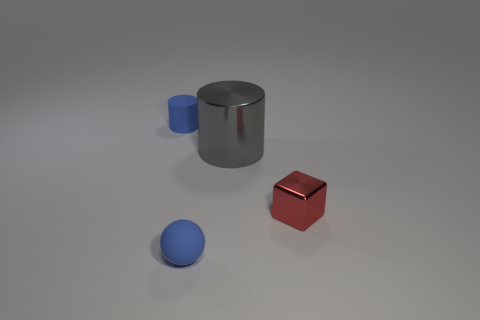Do the rubber cylinder and the matte thing in front of the shiny cylinder have the same color?
Make the answer very short. Yes. Is the number of small blue spheres right of the sphere the same as the number of big things that are in front of the small red block?
Provide a short and direct response. Yes. What number of other objects are there of the same size as the matte ball?
Make the answer very short. 2. The metallic cylinder is what size?
Your answer should be very brief. Large. Are the tiny cube and the blue object that is behind the small matte sphere made of the same material?
Your answer should be compact. No. Is there another big gray shiny thing that has the same shape as the big metallic thing?
Your answer should be very brief. No. What material is the cube that is the same size as the blue cylinder?
Offer a terse response. Metal. There is a rubber object that is in front of the tiny shiny thing; what size is it?
Your response must be concise. Small. Is the size of the blue thing that is behind the large gray shiny thing the same as the blue matte thing that is in front of the gray metallic thing?
Offer a terse response. Yes. How many objects have the same material as the blue cylinder?
Ensure brevity in your answer.  1. 